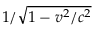Convert formula to latex. <formula><loc_0><loc_0><loc_500><loc_500>1 / { \sqrt { 1 - v ^ { 2 } / c ^ { 2 } } }</formula> 